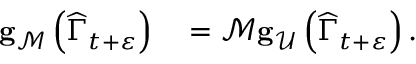Convert formula to latex. <formula><loc_0><loc_0><loc_500><loc_500>\begin{array} { r l } { g _ { \mathcal { M } } \left ( \widehat { \Gamma } _ { t + \varepsilon } \right ) } & = \mathcal { M } g _ { \mathcal { U } } \left ( \widehat { \Gamma } _ { t + \varepsilon } \right ) . } \end{array}</formula> 